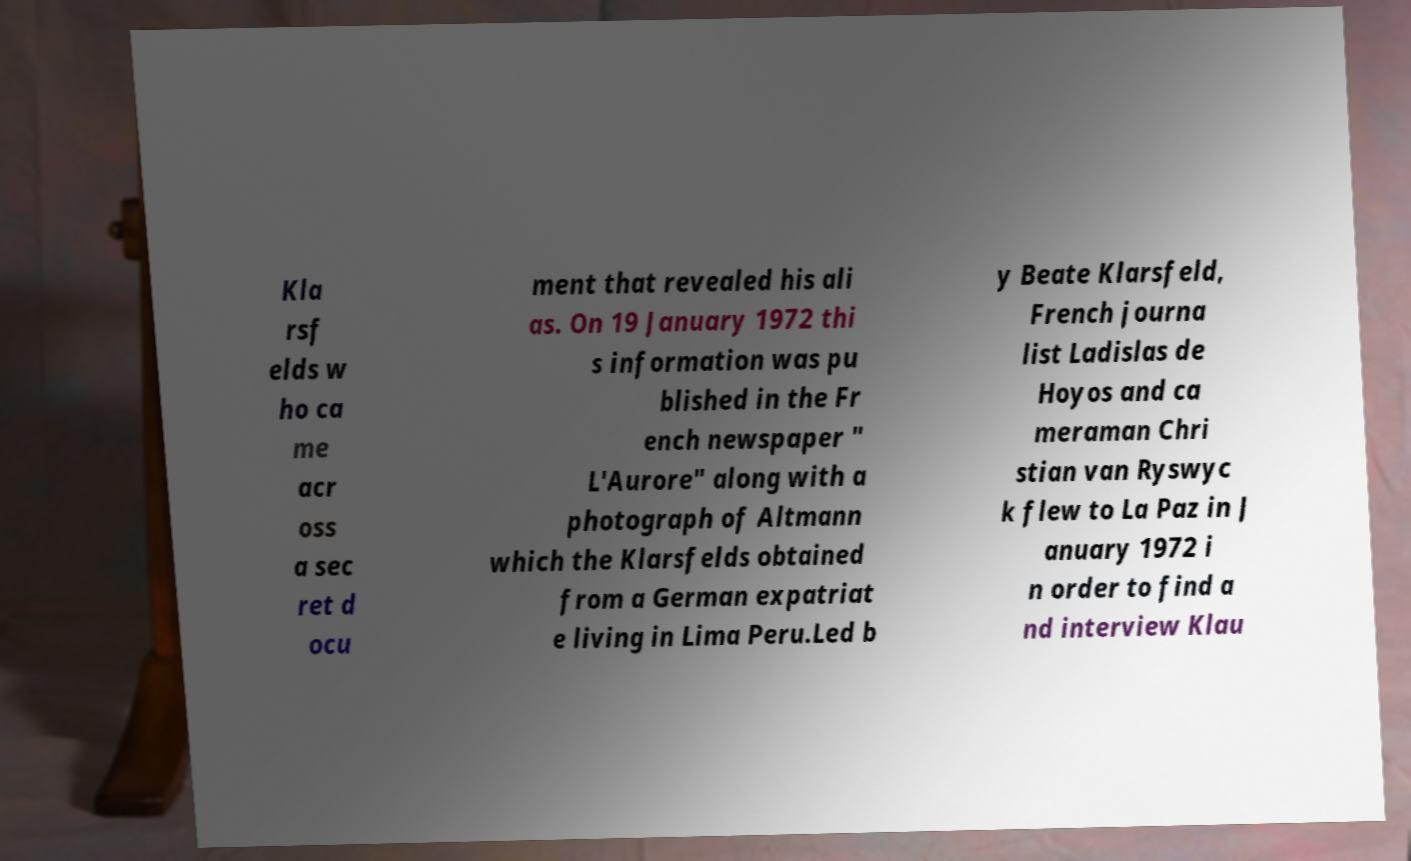Can you accurately transcribe the text from the provided image for me? Kla rsf elds w ho ca me acr oss a sec ret d ocu ment that revealed his ali as. On 19 January 1972 thi s information was pu blished in the Fr ench newspaper " L'Aurore" along with a photograph of Altmann which the Klarsfelds obtained from a German expatriat e living in Lima Peru.Led b y Beate Klarsfeld, French journa list Ladislas de Hoyos and ca meraman Chri stian van Ryswyc k flew to La Paz in J anuary 1972 i n order to find a nd interview Klau 